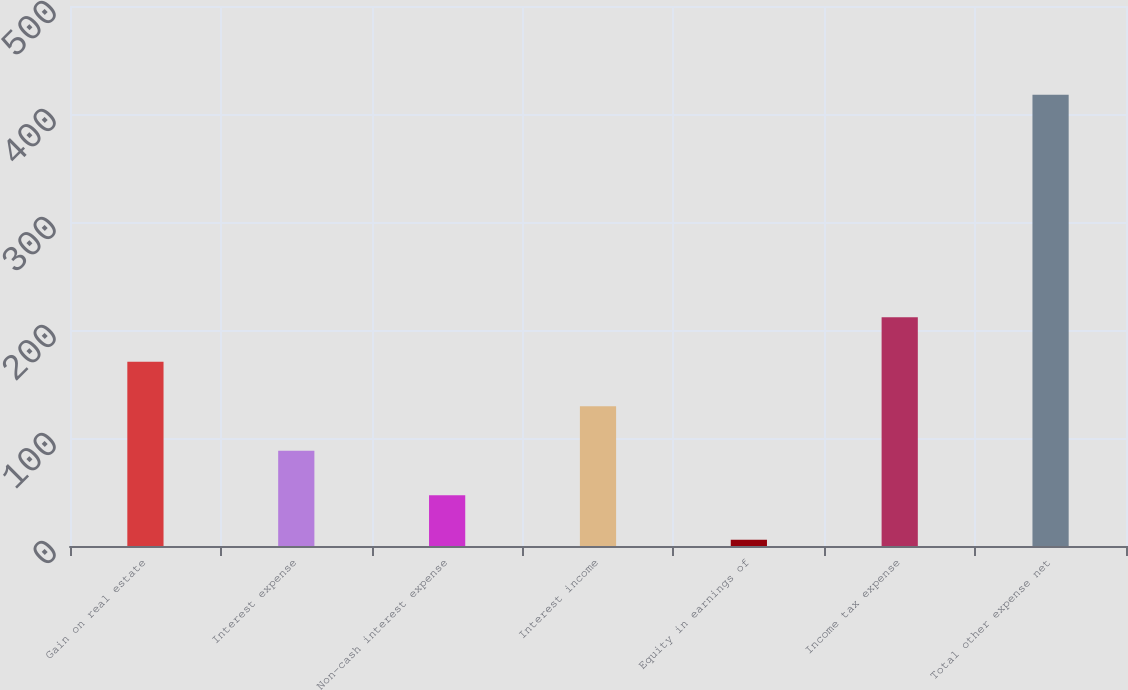Convert chart to OTSL. <chart><loc_0><loc_0><loc_500><loc_500><bar_chart><fcel>Gain on real estate<fcel>Interest expense<fcel>Non-cash interest expense<fcel>Interest income<fcel>Equity in earnings of<fcel>Income tax expense<fcel>Total other expense net<nl><fcel>170.58<fcel>88.14<fcel>46.92<fcel>129.36<fcel>5.7<fcel>211.8<fcel>417.9<nl></chart> 